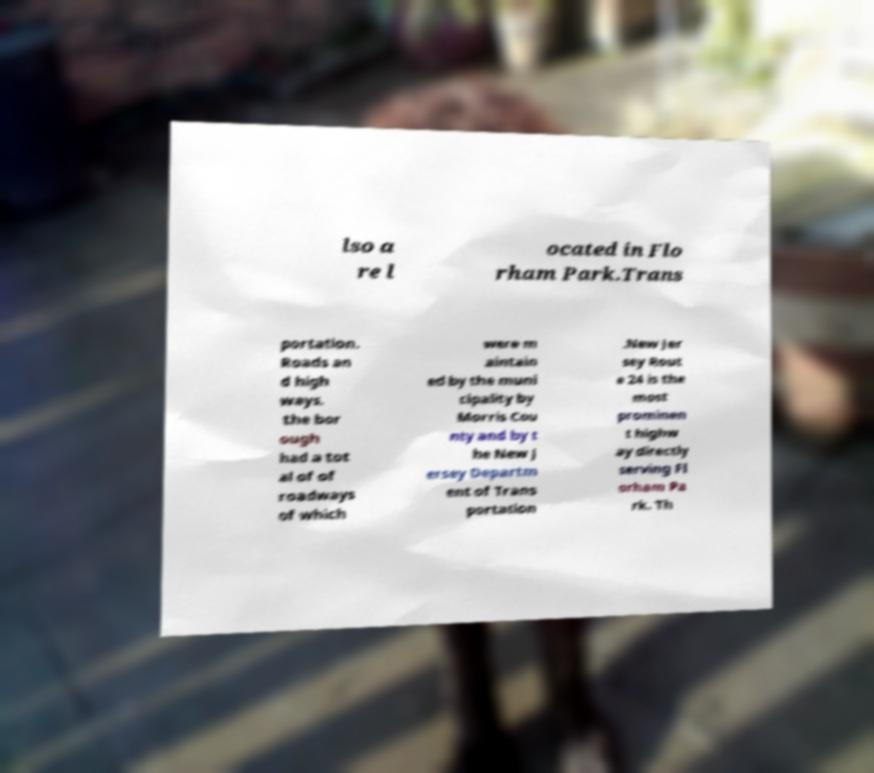Please read and relay the text visible in this image. What does it say? lso a re l ocated in Flo rham Park.Trans portation. Roads an d high ways. the bor ough had a tot al of of roadways of which were m aintain ed by the muni cipality by Morris Cou nty and by t he New J ersey Departm ent of Trans portation .New Jer sey Rout e 24 is the most prominen t highw ay directly serving Fl orham Pa rk. Th 